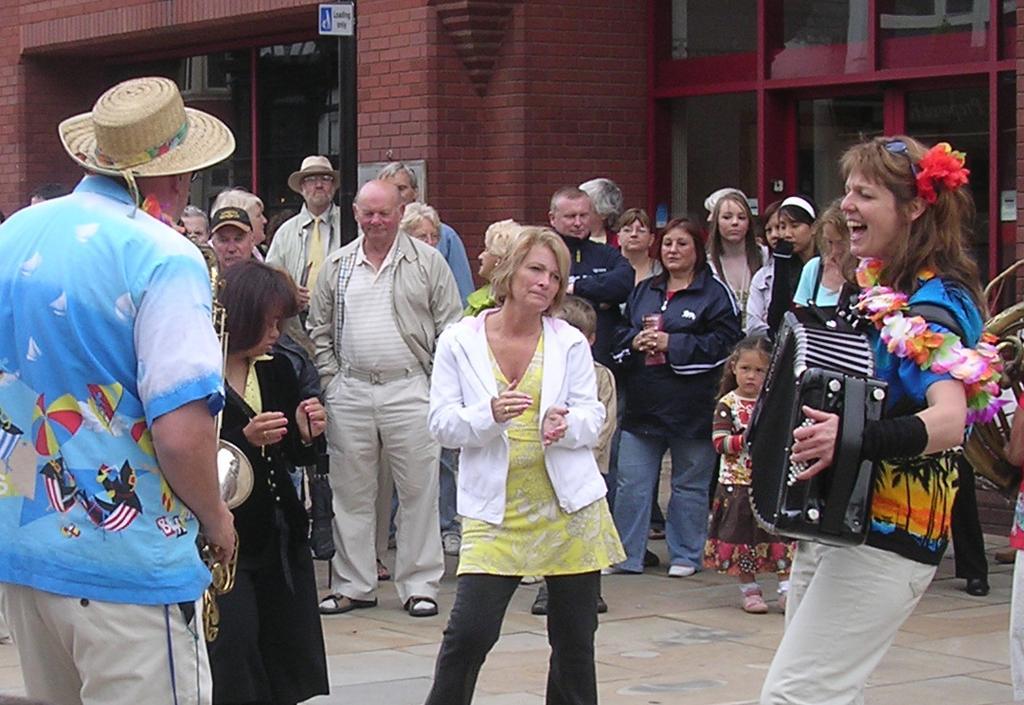Could you give a brief overview of what you see in this image? In this image, there is an outside view of a building. There are some persons standing and wearing colorful clothes. The person who is on the left side of the image playing trumpet. The person who is on the right side of the image playing musical instrument. 